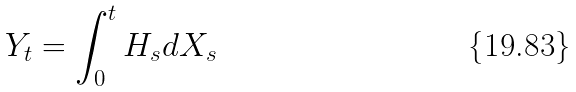Convert formula to latex. <formula><loc_0><loc_0><loc_500><loc_500>Y _ { t } = \int _ { 0 } ^ { t } H _ { s } d X _ { s }</formula> 